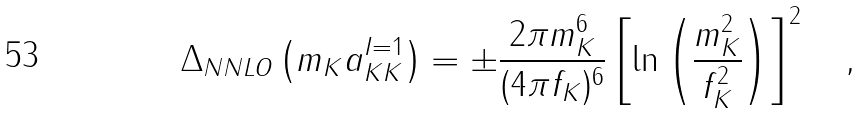<formula> <loc_0><loc_0><loc_500><loc_500>\Delta _ { N N L O } \left ( m _ { K } a _ { K K } ^ { I = 1 } \right ) = \pm \frac { 2 \pi m _ { K } ^ { 6 } } { ( 4 \pi f _ { K } ) ^ { 6 } } \left [ \ln \left ( \frac { m _ { K } ^ { 2 } } { f _ { K } ^ { 2 } } \right ) \right ] ^ { 2 } \quad ,</formula> 